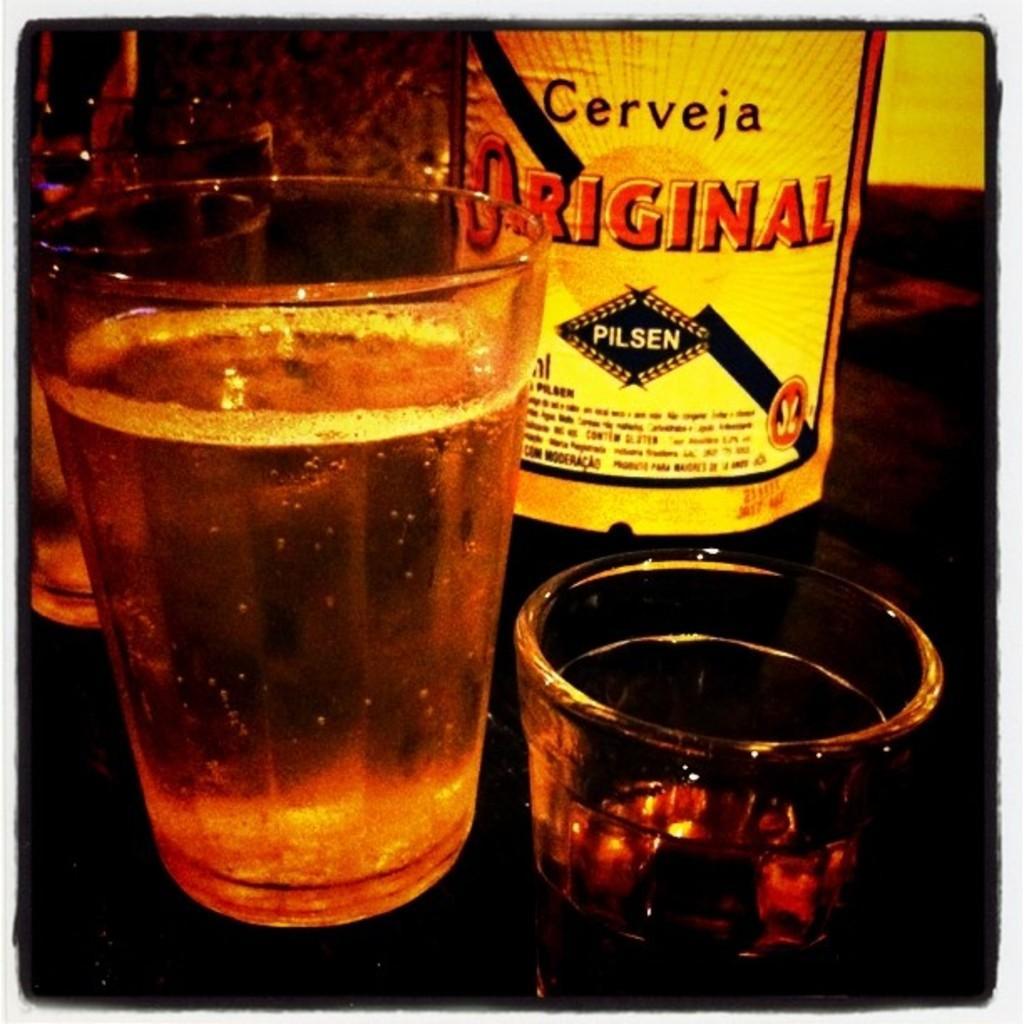Can you describe this image briefly? In this image we can see beverage in glasses and bottles placed on the table. 